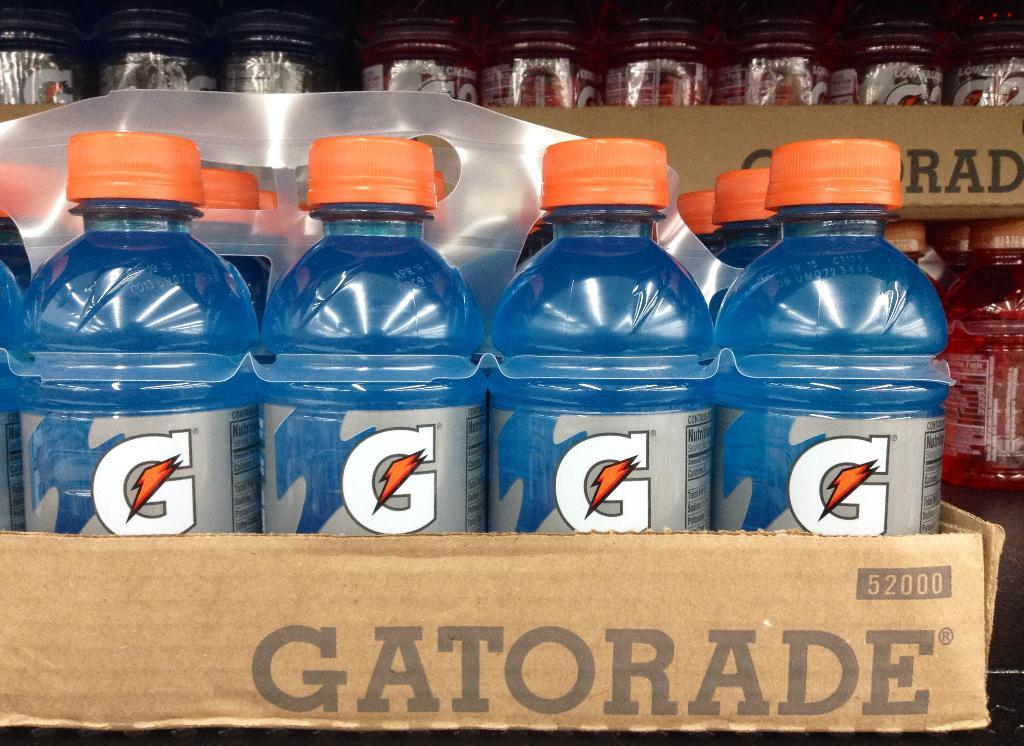What is the main subject of the image? The main subject of the image is many bottles. What can be observed about the bottles in the image? The bottles have labels, and they are kept on boxes. What type of invention is being showcased in the image? There is no invention being showcased in the image; it only features bottles with labels on boxes. What kind of flower can be seen growing near the bottles in the image? There are no flowers present in the image; it only features bottles with labels on boxes. 